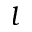Convert formula to latex. <formula><loc_0><loc_0><loc_500><loc_500>l</formula> 